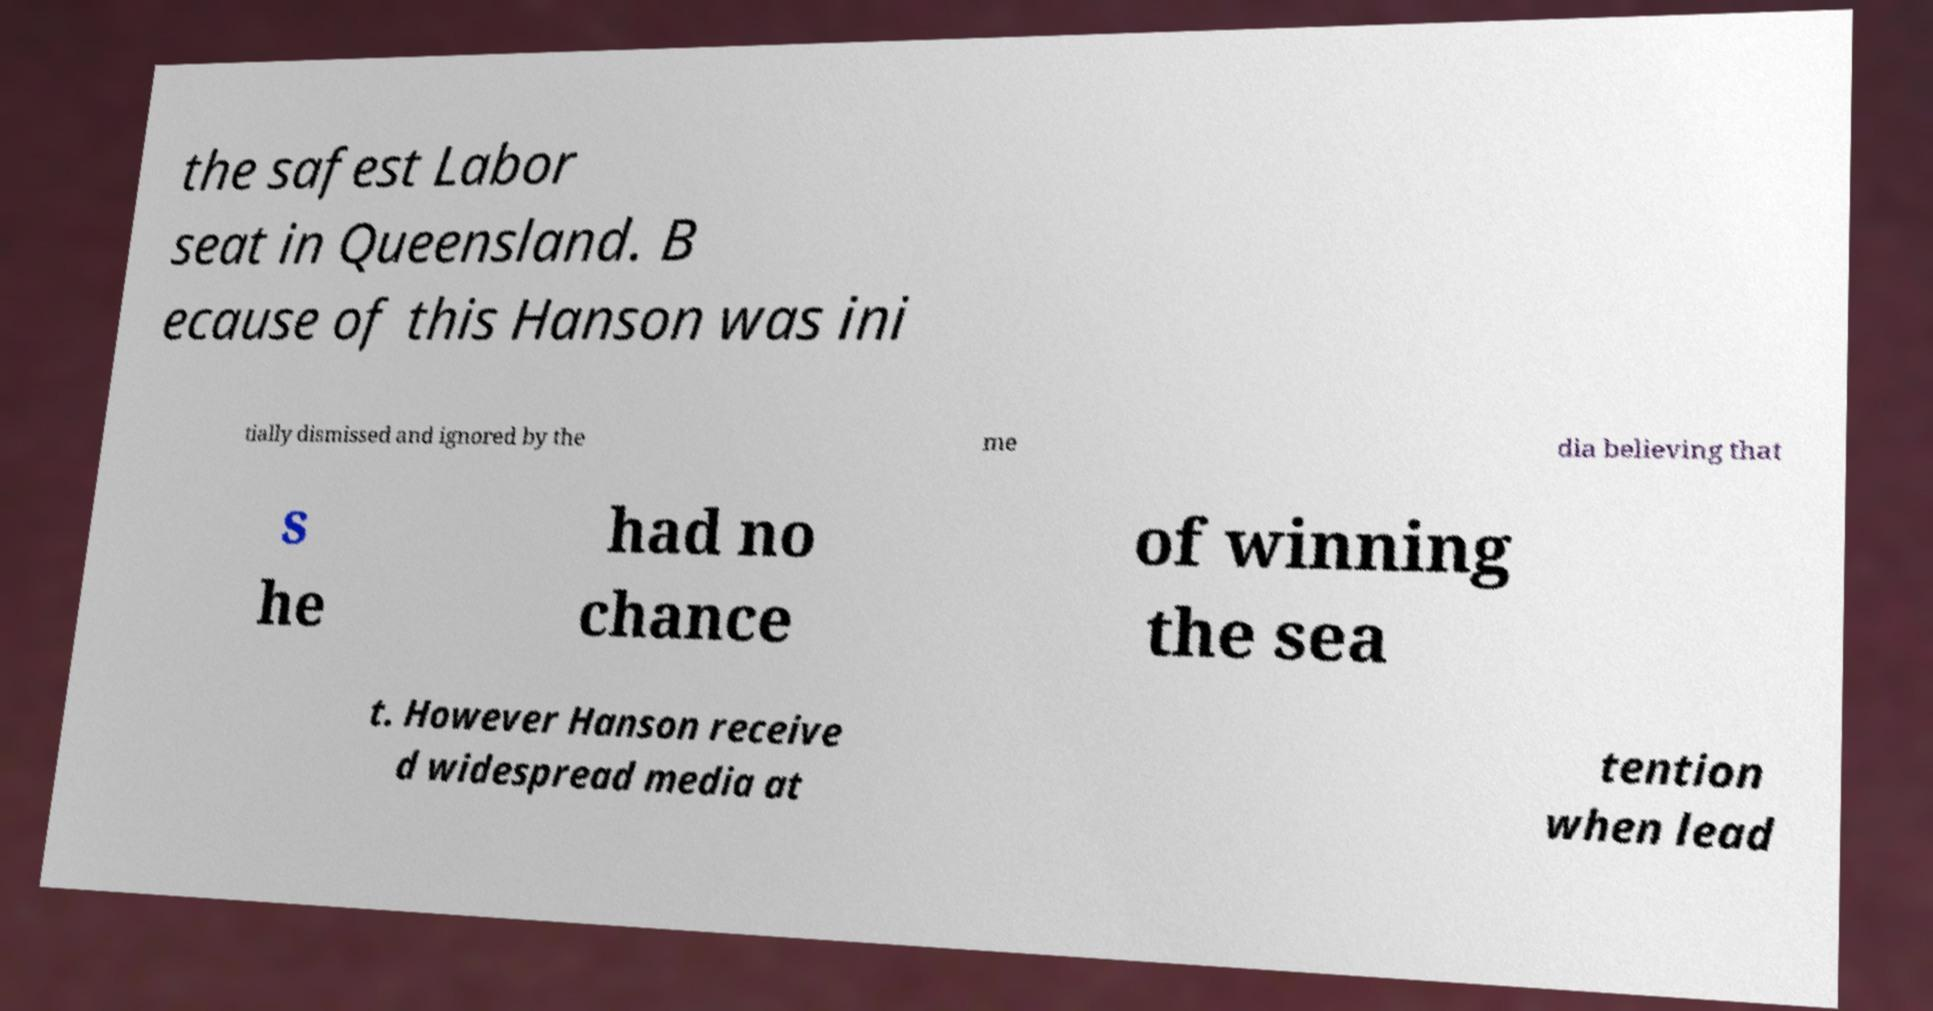There's text embedded in this image that I need extracted. Can you transcribe it verbatim? the safest Labor seat in Queensland. B ecause of this Hanson was ini tially dismissed and ignored by the me dia believing that s he had no chance of winning the sea t. However Hanson receive d widespread media at tention when lead 